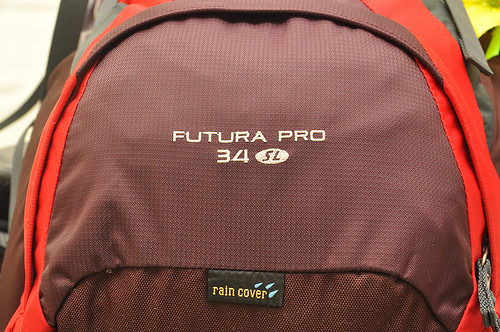<image>
Is the brown bag to the right of the white writing? No. The brown bag is not to the right of the white writing. The horizontal positioning shows a different relationship. 